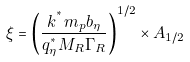<formula> <loc_0><loc_0><loc_500><loc_500>\xi = \left ( \frac { k ^ { ^ { * } } m _ { p } b _ { \eta } } { q _ { \eta } ^ { ^ { * } } M _ { R } \Gamma _ { R } } \right ) ^ { 1 / 2 } \times A _ { 1 / 2 }</formula> 